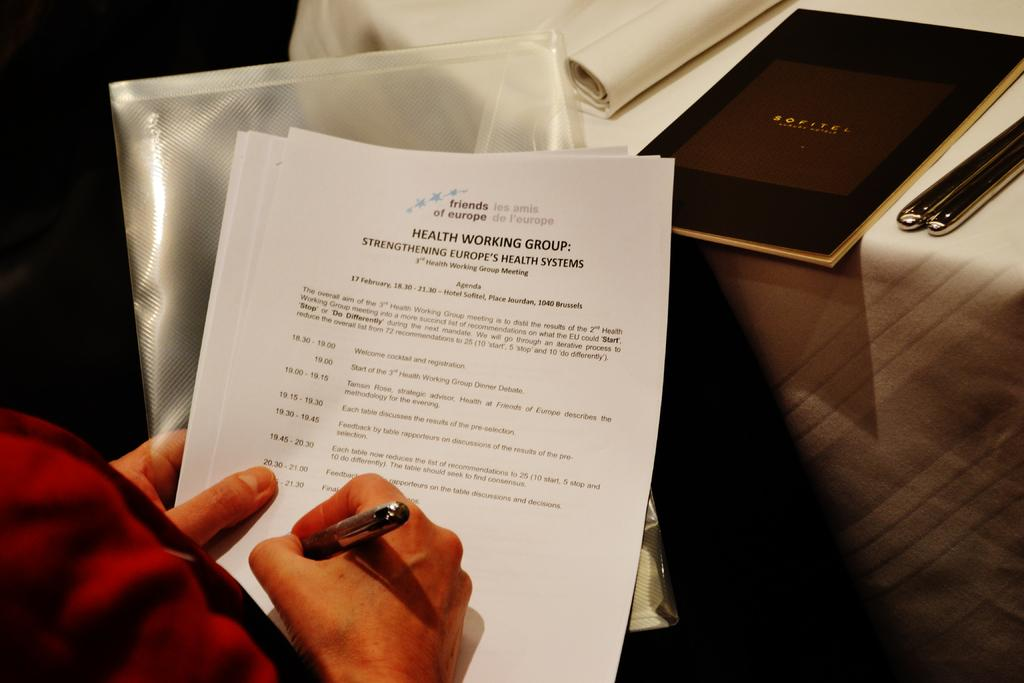Provide a one-sentence caption for the provided image. someone filling out paperwork titled : Health working group. 